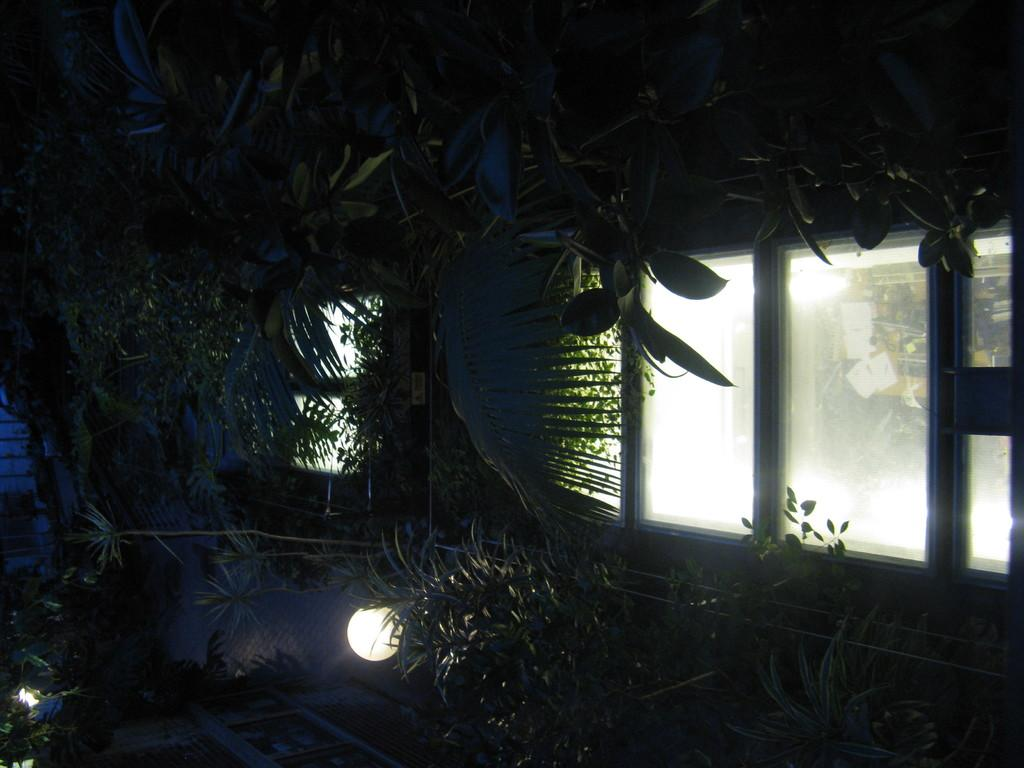What type of vegetation can be seen in the image? There are trees, plants, and grass in the image. What is located at the bottom of the image? There is a light at the bottom of the image. How many windows are visible on the right side of the image? There are many windows on the right side of the image. What can be seen through some of the windows? A door and a wall are visible through some of the windows. How much thunder can be heard in the image? There is no thunder present in the image, as it is a visual representation and does not include sound. 